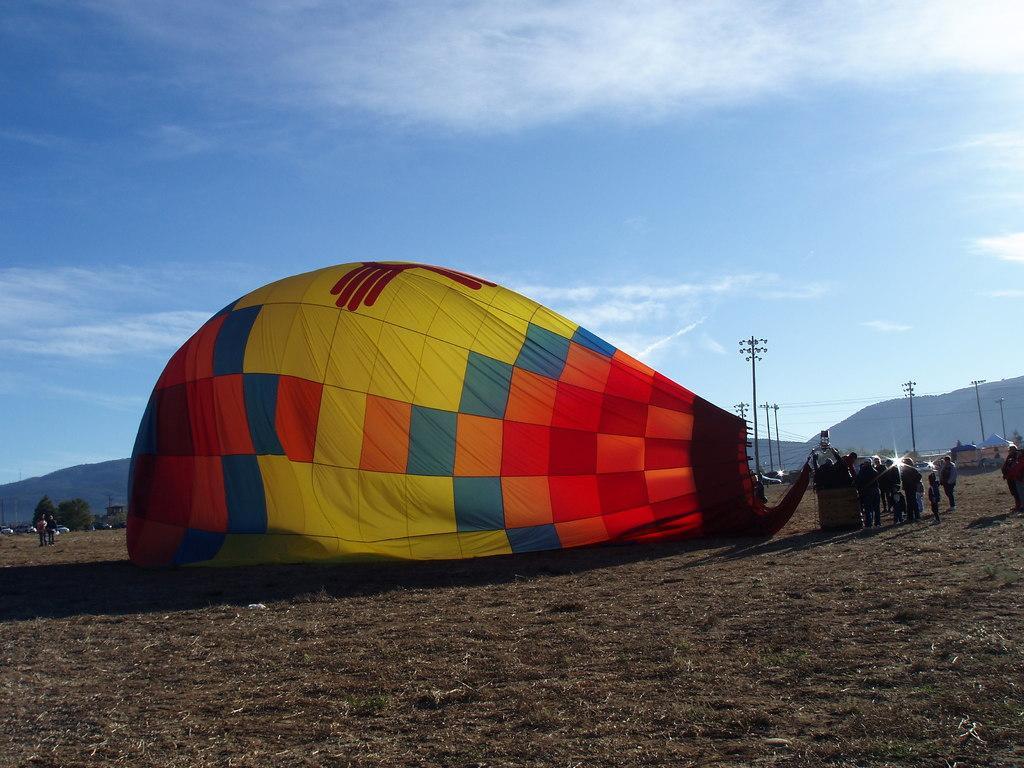How would you summarize this image in a sentence or two? In the image in the center, we can see one hot air balloon. And we can see a few people are standing. In the background, we can see the sky, clouds, hills, trees, poles, vehicles, tents, grass and few people are standing. 